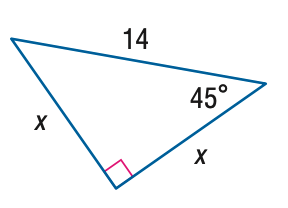Question: Find x.
Choices:
A. 7
B. 7 \sqrt { 2 }
C. 7 \sqrt { 3 }
D. 14
Answer with the letter. Answer: B 